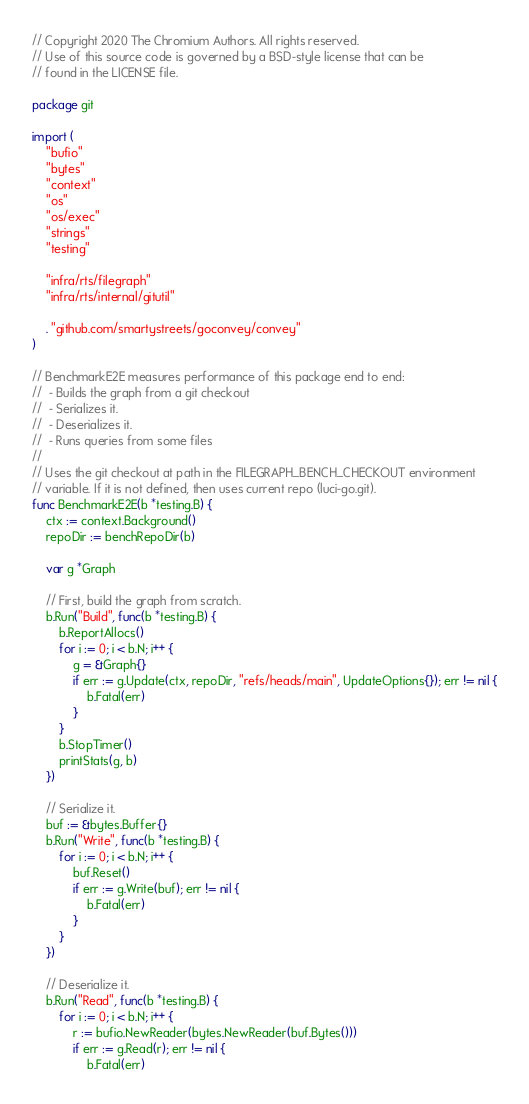<code> <loc_0><loc_0><loc_500><loc_500><_Go_>// Copyright 2020 The Chromium Authors. All rights reserved.
// Use of this source code is governed by a BSD-style license that can be
// found in the LICENSE file.

package git

import (
	"bufio"
	"bytes"
	"context"
	"os"
	"os/exec"
	"strings"
	"testing"

	"infra/rts/filegraph"
	"infra/rts/internal/gitutil"

	. "github.com/smartystreets/goconvey/convey"
)

// BenchmarkE2E measures performance of this package end to end:
//  - Builds the graph from a git checkout
//  - Serializes it.
//  - Deserializes it.
//  - Runs queries from some files
//
// Uses the git checkout at path in the FILEGRAPH_BENCH_CHECKOUT environment
// variable. If it is not defined, then uses current repo (luci-go.git).
func BenchmarkE2E(b *testing.B) {
	ctx := context.Background()
	repoDir := benchRepoDir(b)

	var g *Graph

	// First, build the graph from scratch.
	b.Run("Build", func(b *testing.B) {
		b.ReportAllocs()
		for i := 0; i < b.N; i++ {
			g = &Graph{}
			if err := g.Update(ctx, repoDir, "refs/heads/main", UpdateOptions{}); err != nil {
				b.Fatal(err)
			}
		}
		b.StopTimer()
		printStats(g, b)
	})

	// Serialize it.
	buf := &bytes.Buffer{}
	b.Run("Write", func(b *testing.B) {
		for i := 0; i < b.N; i++ {
			buf.Reset()
			if err := g.Write(buf); err != nil {
				b.Fatal(err)
			}
		}
	})

	// Deserialize it.
	b.Run("Read", func(b *testing.B) {
		for i := 0; i < b.N; i++ {
			r := bufio.NewReader(bytes.NewReader(buf.Bytes()))
			if err := g.Read(r); err != nil {
				b.Fatal(err)</code> 